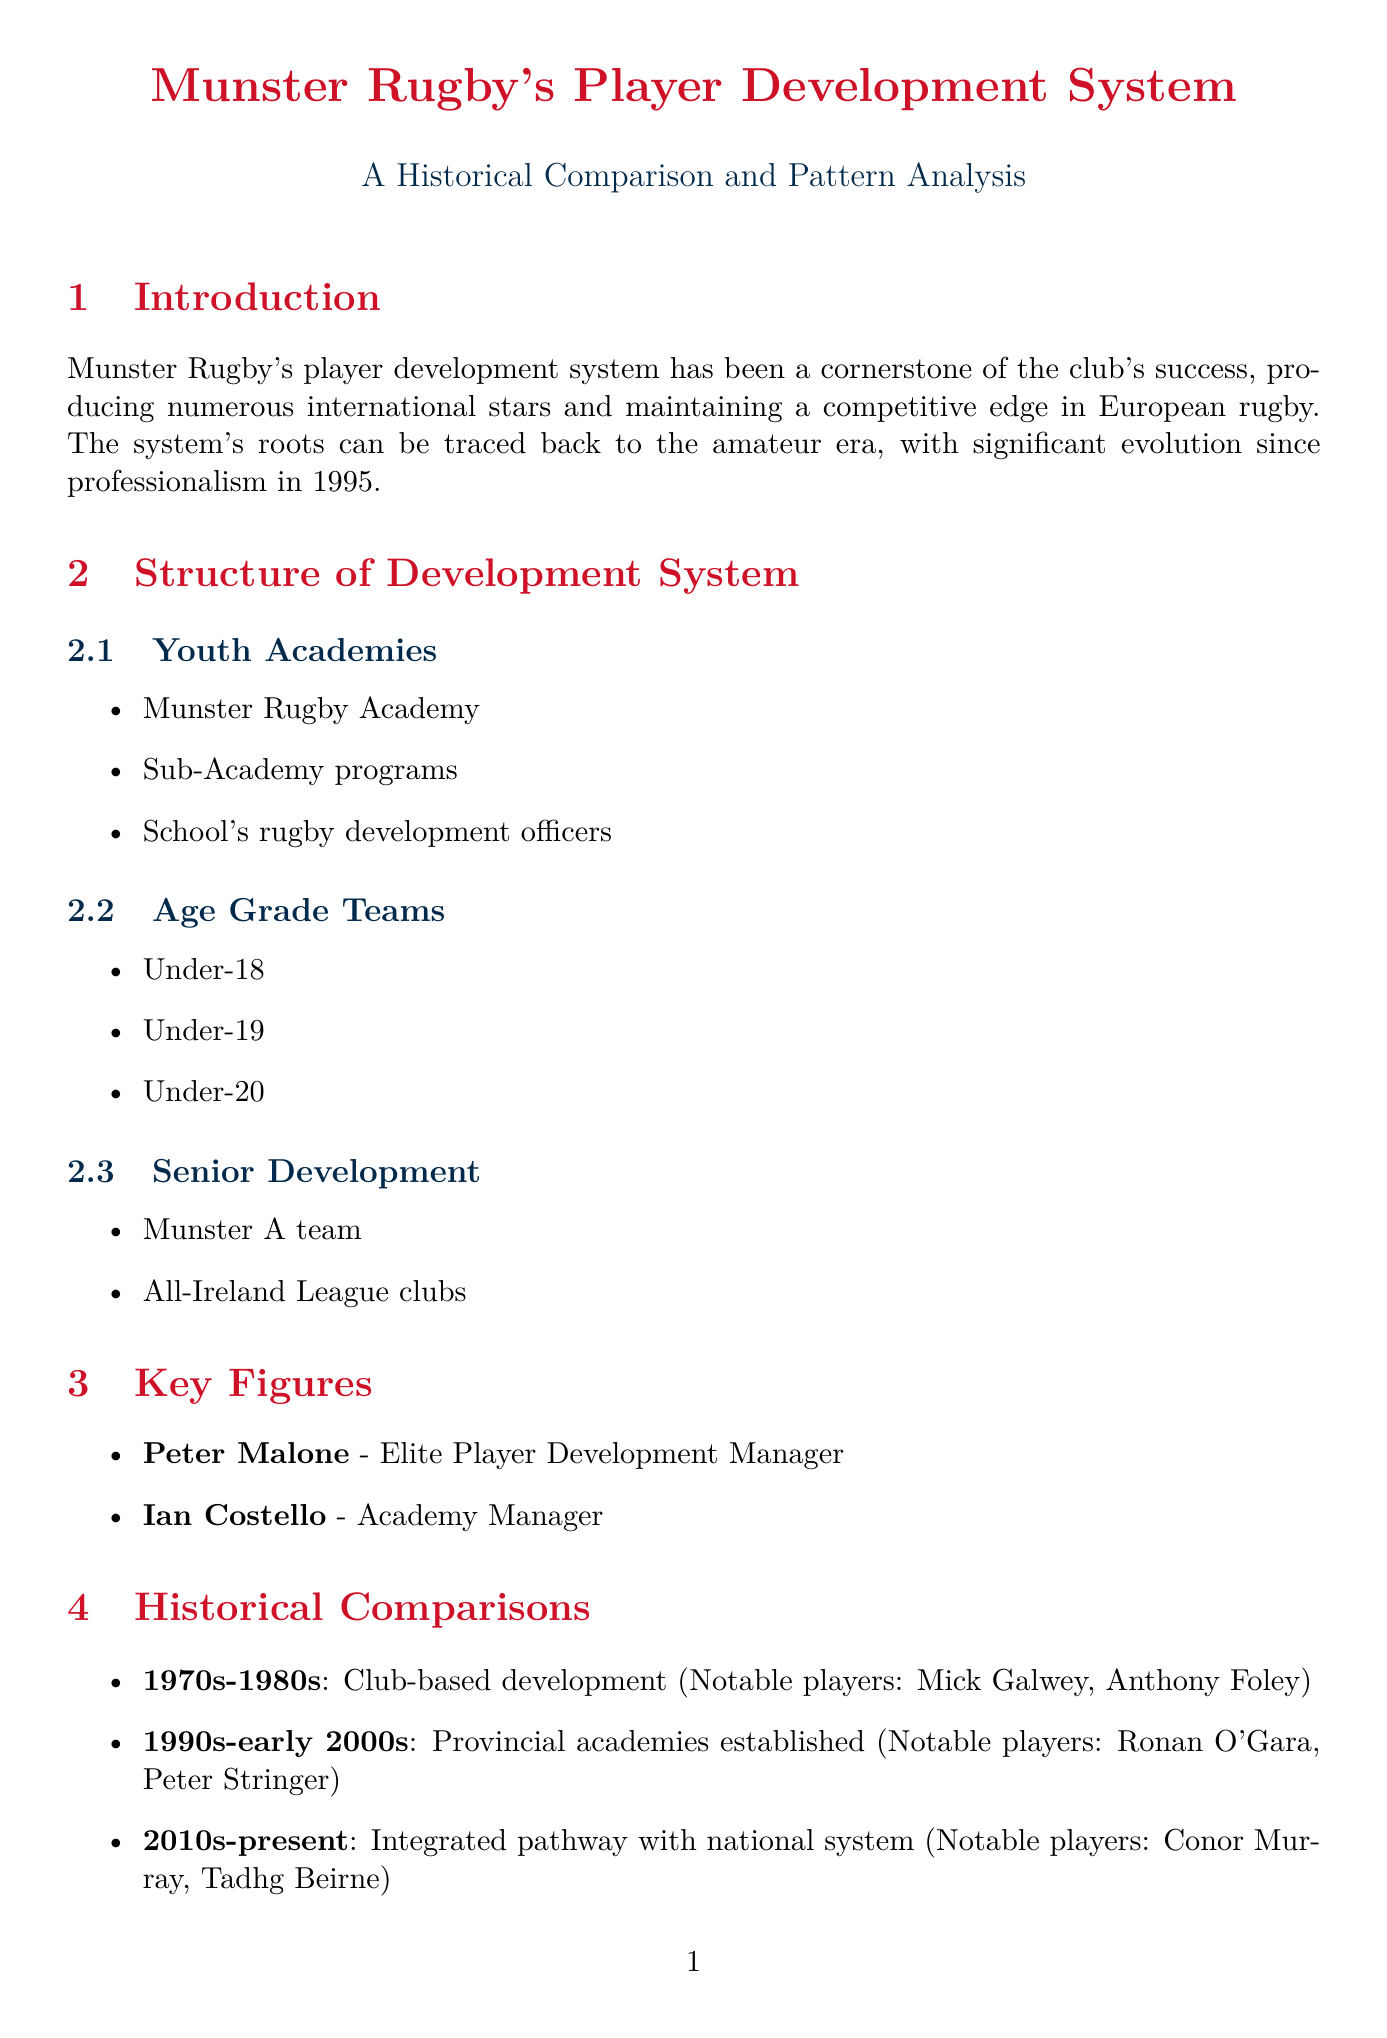What is the primary focus of Munster Rugby's player development system? The primary focus has been on producing numerous international stars and maintaining a competitive edge in European rugby.
Answer: Producing international stars Who oversees the transition of players from academy to senior squad? Peter Malone's role as Elite Player Development Manager involves overseeing this transition.
Answer: Peter Malone What notable players were developed in the 1990s to early 2000s? The notable players from this period include Ronan O'Gara and Peter Stringer.
Answer: Ronan O'Gara, Peter Stringer What pattern suggests the importance of early talent identification? The example of Keith Earls being scouted at age 12 highlights this pattern.
Answer: Early identification of talent How does Munster's model compare to Leinster's regarding school systems? Both models share a strong school system, but Leinster has a higher population base and more private schools.
Answer: Strong school system Which emerging talent is mentioned in the future prospects section? The future prospects section lists Alex Kendellen as one of the emerging talents.
Answer: Alex Kendellen What key challenge arises from competition for talent? The key challenge is an increased focus on non-traditional rugby schools.
Answer: Non-traditional rugby schools What system enhancement involves sports science collaboration? A partnership with University of Limerick for sports science integration is one system enhancement.
Answer: Partnership with University of Limerick How has Munster's player development system evolved since 1995? The system has evolved significantly while maintaining core values and adapting to modern rugby demands.
Answer: Evolved significantly 